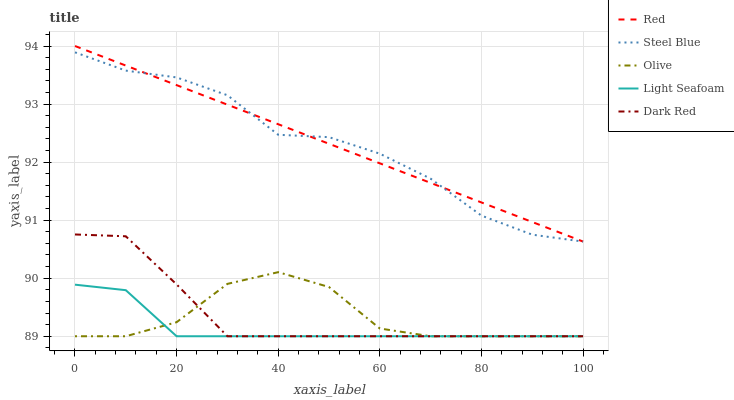Does Light Seafoam have the minimum area under the curve?
Answer yes or no. Yes. Does Red have the maximum area under the curve?
Answer yes or no. Yes. Does Dark Red have the minimum area under the curve?
Answer yes or no. No. Does Dark Red have the maximum area under the curve?
Answer yes or no. No. Is Red the smoothest?
Answer yes or no. Yes. Is Olive the roughest?
Answer yes or no. Yes. Is Dark Red the smoothest?
Answer yes or no. No. Is Dark Red the roughest?
Answer yes or no. No. Does Steel Blue have the lowest value?
Answer yes or no. No. Does Dark Red have the highest value?
Answer yes or no. No. Is Dark Red less than Steel Blue?
Answer yes or no. Yes. Is Red greater than Light Seafoam?
Answer yes or no. Yes. Does Dark Red intersect Steel Blue?
Answer yes or no. No. 